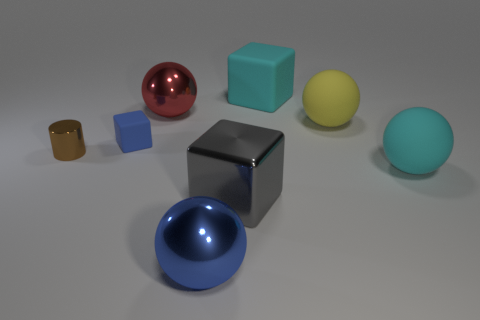Add 1 large blue shiny objects. How many objects exist? 9 Subtract all cylinders. How many objects are left? 7 Add 3 big cyan cubes. How many big cyan cubes exist? 4 Subtract 0 gray spheres. How many objects are left? 8 Subtract all shiny objects. Subtract all tiny blocks. How many objects are left? 3 Add 6 large blue objects. How many large blue objects are left? 7 